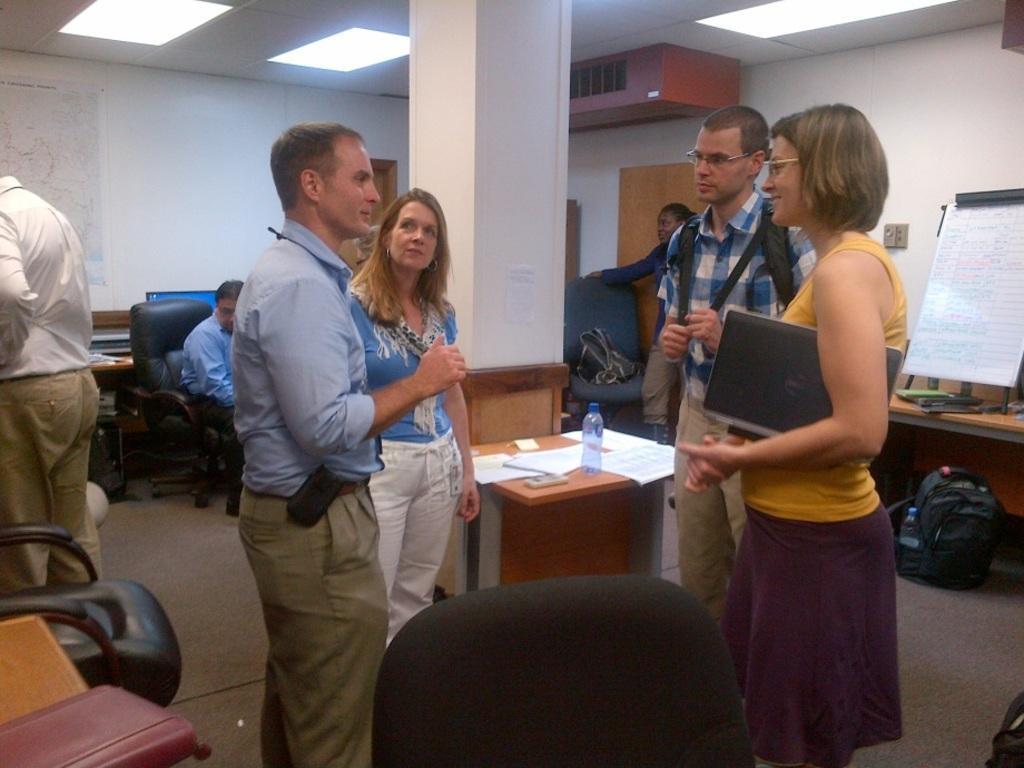What are the people in the image doing? The people in the image are standing. Can you describe the position of one person in the image? There is a person sitting on a chair in the image. What type of wire is being used by the person sitting on the chair? There is no wire visible in the image, and therefore no such activity can be observed. 